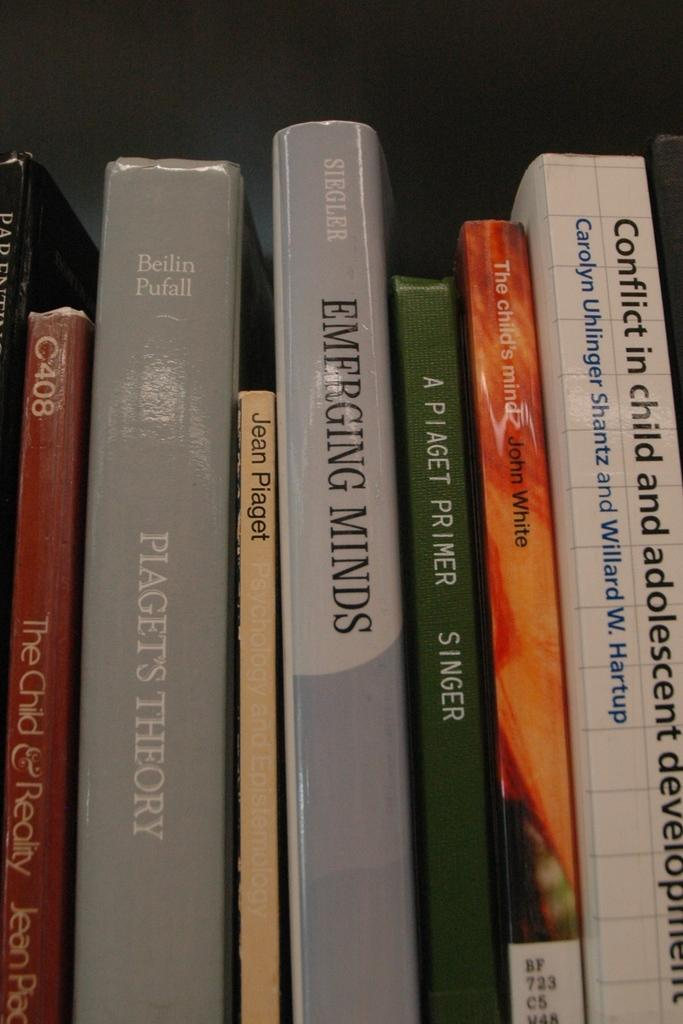<image>
Write a terse but informative summary of the picture. a line of books with one of them that is called 'emerging minds' 